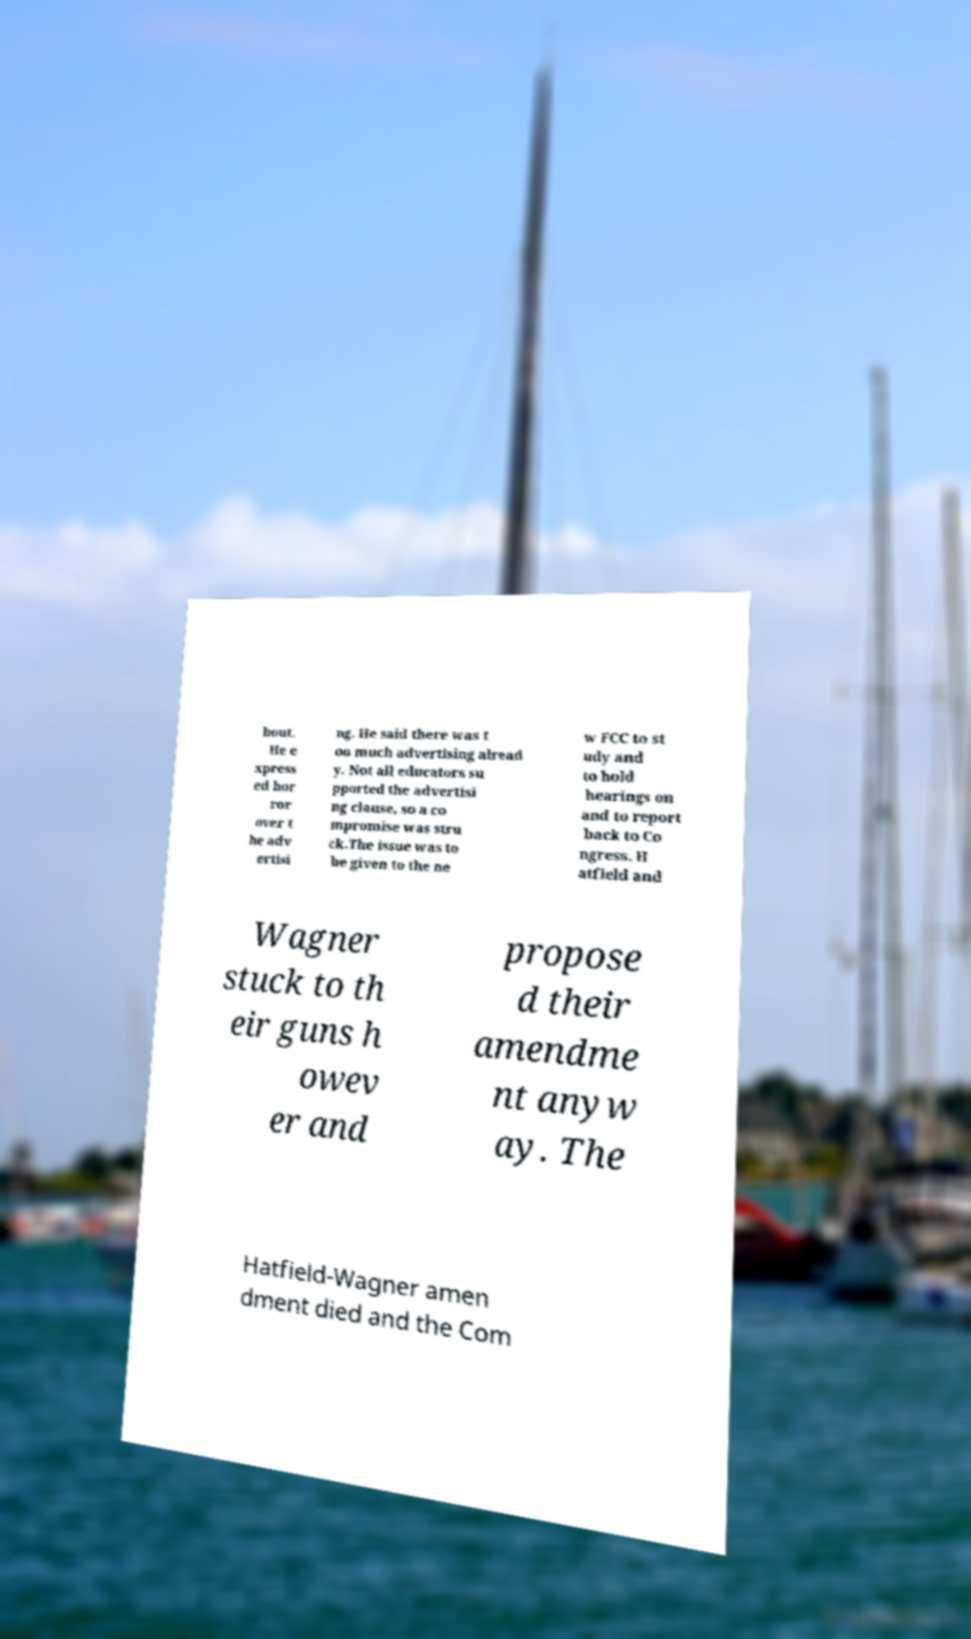Please identify and transcribe the text found in this image. bout. He e xpress ed hor ror over t he adv ertisi ng. He said there was t oo much advertising alread y. Not all educators su pported the advertisi ng clause, so a co mpromise was stru ck.The issue was to be given to the ne w FCC to st udy and to hold hearings on and to report back to Co ngress. H atfield and Wagner stuck to th eir guns h owev er and propose d their amendme nt anyw ay. The Hatfield-Wagner amen dment died and the Com 